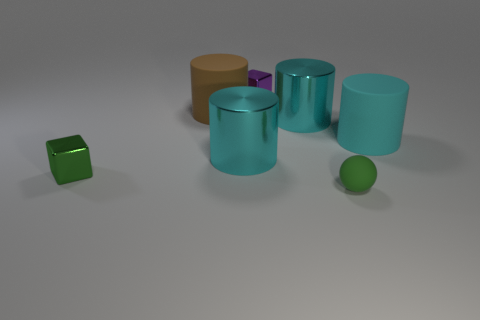Are there fewer purple blocks on the right side of the purple metallic thing than matte spheres?
Offer a very short reply. Yes. Is there anything else that is the same size as the purple cube?
Provide a succinct answer. Yes. There is a green thing that is in front of the tiny green object that is to the left of the green sphere; what size is it?
Offer a terse response. Small. Is there anything else that is the same shape as the purple thing?
Offer a terse response. Yes. Is the number of tiny green cubes less than the number of yellow rubber spheres?
Your response must be concise. No. What is the material of the big object that is in front of the brown rubber cylinder and left of the tiny purple thing?
Give a very brief answer. Metal. Is there a green shiny thing that is behind the tiny metal object that is in front of the purple cube?
Provide a short and direct response. No. How many things are small green balls or cyan metallic objects?
Ensure brevity in your answer.  3. There is a metal thing that is in front of the big cyan rubber cylinder and on the right side of the big brown matte cylinder; what shape is it?
Offer a terse response. Cylinder. Is the purple thing that is on the right side of the brown cylinder made of the same material as the big brown object?
Offer a very short reply. No. 